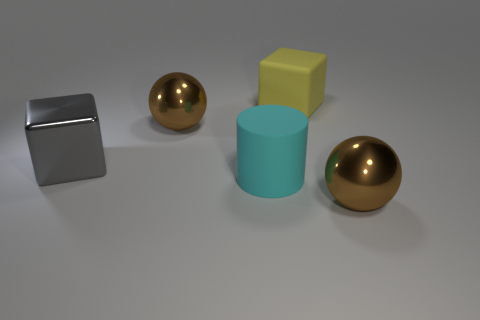Add 2 big red metallic cylinders. How many objects exist? 7 Subtract all spheres. How many objects are left? 3 Add 3 brown shiny things. How many brown shiny things are left? 5 Add 1 tiny red cylinders. How many tiny red cylinders exist? 1 Subtract 1 brown spheres. How many objects are left? 4 Subtract all yellow matte balls. Subtract all rubber things. How many objects are left? 3 